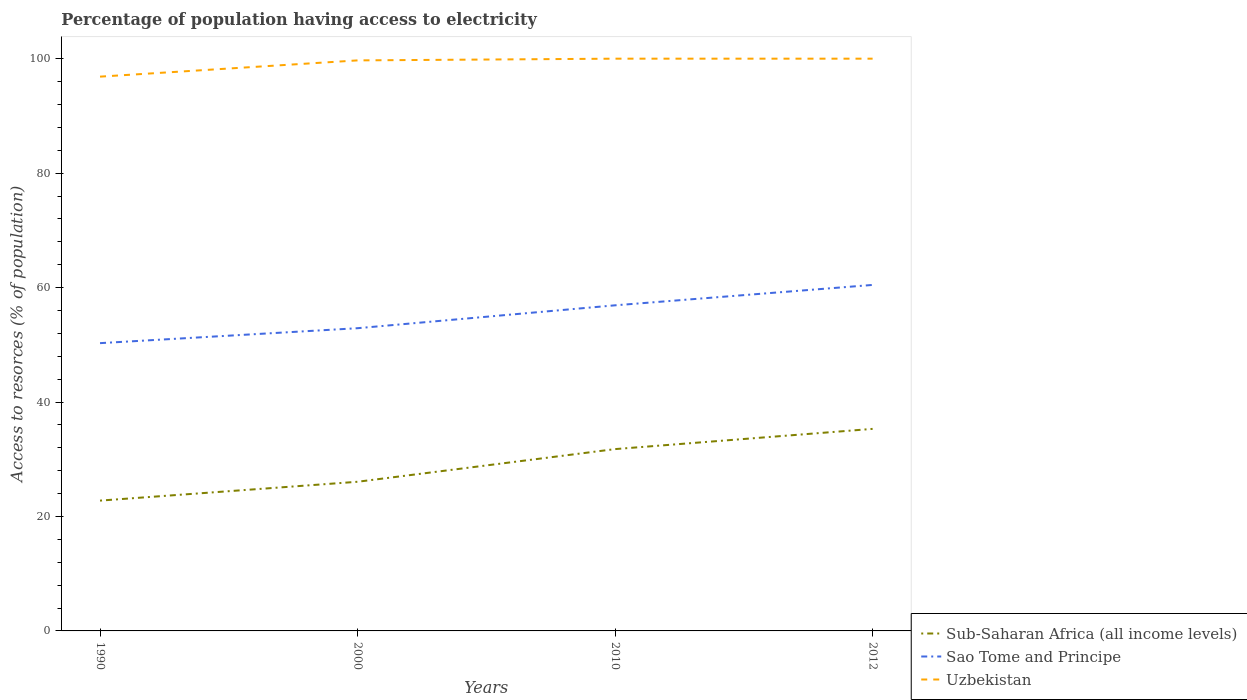How many different coloured lines are there?
Your response must be concise. 3. Across all years, what is the maximum percentage of population having access to electricity in Uzbekistan?
Give a very brief answer. 96.86. What is the difference between the highest and the second highest percentage of population having access to electricity in Uzbekistan?
Keep it short and to the point. 3.14. How many lines are there?
Ensure brevity in your answer.  3. How many years are there in the graph?
Give a very brief answer. 4. Does the graph contain any zero values?
Provide a succinct answer. No. How many legend labels are there?
Provide a succinct answer. 3. What is the title of the graph?
Make the answer very short. Percentage of population having access to electricity. Does "Panama" appear as one of the legend labels in the graph?
Offer a very short reply. No. What is the label or title of the Y-axis?
Keep it short and to the point. Access to resorces (% of population). What is the Access to resorces (% of population) of Sub-Saharan Africa (all income levels) in 1990?
Offer a very short reply. 22.77. What is the Access to resorces (% of population) in Sao Tome and Principe in 1990?
Give a very brief answer. 50.29. What is the Access to resorces (% of population) in Uzbekistan in 1990?
Keep it short and to the point. 96.86. What is the Access to resorces (% of population) of Sub-Saharan Africa (all income levels) in 2000?
Your answer should be very brief. 26.06. What is the Access to resorces (% of population) in Sao Tome and Principe in 2000?
Offer a very short reply. 52.9. What is the Access to resorces (% of population) in Uzbekistan in 2000?
Provide a succinct answer. 99.7. What is the Access to resorces (% of population) of Sub-Saharan Africa (all income levels) in 2010?
Offer a very short reply. 31.77. What is the Access to resorces (% of population) in Sao Tome and Principe in 2010?
Your answer should be compact. 56.9. What is the Access to resorces (% of population) in Uzbekistan in 2010?
Keep it short and to the point. 100. What is the Access to resorces (% of population) in Sub-Saharan Africa (all income levels) in 2012?
Ensure brevity in your answer.  35.31. What is the Access to resorces (% of population) in Sao Tome and Principe in 2012?
Make the answer very short. 60.46. What is the Access to resorces (% of population) of Uzbekistan in 2012?
Provide a succinct answer. 100. Across all years, what is the maximum Access to resorces (% of population) in Sub-Saharan Africa (all income levels)?
Make the answer very short. 35.31. Across all years, what is the maximum Access to resorces (% of population) in Sao Tome and Principe?
Offer a terse response. 60.46. Across all years, what is the maximum Access to resorces (% of population) of Uzbekistan?
Your answer should be compact. 100. Across all years, what is the minimum Access to resorces (% of population) of Sub-Saharan Africa (all income levels)?
Keep it short and to the point. 22.77. Across all years, what is the minimum Access to resorces (% of population) of Sao Tome and Principe?
Provide a short and direct response. 50.29. Across all years, what is the minimum Access to resorces (% of population) in Uzbekistan?
Make the answer very short. 96.86. What is the total Access to resorces (% of population) in Sub-Saharan Africa (all income levels) in the graph?
Keep it short and to the point. 115.92. What is the total Access to resorces (% of population) of Sao Tome and Principe in the graph?
Make the answer very short. 220.55. What is the total Access to resorces (% of population) in Uzbekistan in the graph?
Offer a very short reply. 396.56. What is the difference between the Access to resorces (% of population) of Sub-Saharan Africa (all income levels) in 1990 and that in 2000?
Offer a very short reply. -3.29. What is the difference between the Access to resorces (% of population) in Sao Tome and Principe in 1990 and that in 2000?
Your answer should be compact. -2.61. What is the difference between the Access to resorces (% of population) in Uzbekistan in 1990 and that in 2000?
Provide a succinct answer. -2.84. What is the difference between the Access to resorces (% of population) in Sub-Saharan Africa (all income levels) in 1990 and that in 2010?
Ensure brevity in your answer.  -9. What is the difference between the Access to resorces (% of population) in Sao Tome and Principe in 1990 and that in 2010?
Make the answer very short. -6.61. What is the difference between the Access to resorces (% of population) of Uzbekistan in 1990 and that in 2010?
Your answer should be very brief. -3.14. What is the difference between the Access to resorces (% of population) in Sub-Saharan Africa (all income levels) in 1990 and that in 2012?
Ensure brevity in your answer.  -12.53. What is the difference between the Access to resorces (% of population) of Sao Tome and Principe in 1990 and that in 2012?
Give a very brief answer. -10.17. What is the difference between the Access to resorces (% of population) of Uzbekistan in 1990 and that in 2012?
Provide a short and direct response. -3.14. What is the difference between the Access to resorces (% of population) of Sub-Saharan Africa (all income levels) in 2000 and that in 2010?
Give a very brief answer. -5.71. What is the difference between the Access to resorces (% of population) of Sub-Saharan Africa (all income levels) in 2000 and that in 2012?
Make the answer very short. -9.24. What is the difference between the Access to resorces (% of population) of Sao Tome and Principe in 2000 and that in 2012?
Keep it short and to the point. -7.56. What is the difference between the Access to resorces (% of population) of Sub-Saharan Africa (all income levels) in 2010 and that in 2012?
Ensure brevity in your answer.  -3.53. What is the difference between the Access to resorces (% of population) in Sao Tome and Principe in 2010 and that in 2012?
Provide a succinct answer. -3.56. What is the difference between the Access to resorces (% of population) of Uzbekistan in 2010 and that in 2012?
Your response must be concise. 0. What is the difference between the Access to resorces (% of population) in Sub-Saharan Africa (all income levels) in 1990 and the Access to resorces (% of population) in Sao Tome and Principe in 2000?
Provide a succinct answer. -30.13. What is the difference between the Access to resorces (% of population) of Sub-Saharan Africa (all income levels) in 1990 and the Access to resorces (% of population) of Uzbekistan in 2000?
Give a very brief answer. -76.93. What is the difference between the Access to resorces (% of population) of Sao Tome and Principe in 1990 and the Access to resorces (% of population) of Uzbekistan in 2000?
Your answer should be very brief. -49.41. What is the difference between the Access to resorces (% of population) of Sub-Saharan Africa (all income levels) in 1990 and the Access to resorces (% of population) of Sao Tome and Principe in 2010?
Provide a short and direct response. -34.13. What is the difference between the Access to resorces (% of population) of Sub-Saharan Africa (all income levels) in 1990 and the Access to resorces (% of population) of Uzbekistan in 2010?
Offer a very short reply. -77.23. What is the difference between the Access to resorces (% of population) of Sao Tome and Principe in 1990 and the Access to resorces (% of population) of Uzbekistan in 2010?
Keep it short and to the point. -49.71. What is the difference between the Access to resorces (% of population) of Sub-Saharan Africa (all income levels) in 1990 and the Access to resorces (% of population) of Sao Tome and Principe in 2012?
Your response must be concise. -37.69. What is the difference between the Access to resorces (% of population) of Sub-Saharan Africa (all income levels) in 1990 and the Access to resorces (% of population) of Uzbekistan in 2012?
Ensure brevity in your answer.  -77.23. What is the difference between the Access to resorces (% of population) of Sao Tome and Principe in 1990 and the Access to resorces (% of population) of Uzbekistan in 2012?
Your answer should be very brief. -49.71. What is the difference between the Access to resorces (% of population) in Sub-Saharan Africa (all income levels) in 2000 and the Access to resorces (% of population) in Sao Tome and Principe in 2010?
Offer a very short reply. -30.84. What is the difference between the Access to resorces (% of population) in Sub-Saharan Africa (all income levels) in 2000 and the Access to resorces (% of population) in Uzbekistan in 2010?
Your answer should be very brief. -73.94. What is the difference between the Access to resorces (% of population) of Sao Tome and Principe in 2000 and the Access to resorces (% of population) of Uzbekistan in 2010?
Ensure brevity in your answer.  -47.1. What is the difference between the Access to resorces (% of population) in Sub-Saharan Africa (all income levels) in 2000 and the Access to resorces (% of population) in Sao Tome and Principe in 2012?
Provide a short and direct response. -34.4. What is the difference between the Access to resorces (% of population) in Sub-Saharan Africa (all income levels) in 2000 and the Access to resorces (% of population) in Uzbekistan in 2012?
Provide a succinct answer. -73.94. What is the difference between the Access to resorces (% of population) of Sao Tome and Principe in 2000 and the Access to resorces (% of population) of Uzbekistan in 2012?
Your response must be concise. -47.1. What is the difference between the Access to resorces (% of population) in Sub-Saharan Africa (all income levels) in 2010 and the Access to resorces (% of population) in Sao Tome and Principe in 2012?
Your answer should be compact. -28.69. What is the difference between the Access to resorces (% of population) in Sub-Saharan Africa (all income levels) in 2010 and the Access to resorces (% of population) in Uzbekistan in 2012?
Give a very brief answer. -68.23. What is the difference between the Access to resorces (% of population) of Sao Tome and Principe in 2010 and the Access to resorces (% of population) of Uzbekistan in 2012?
Keep it short and to the point. -43.1. What is the average Access to resorces (% of population) of Sub-Saharan Africa (all income levels) per year?
Make the answer very short. 28.98. What is the average Access to resorces (% of population) in Sao Tome and Principe per year?
Provide a short and direct response. 55.14. What is the average Access to resorces (% of population) in Uzbekistan per year?
Your response must be concise. 99.14. In the year 1990, what is the difference between the Access to resorces (% of population) in Sub-Saharan Africa (all income levels) and Access to resorces (% of population) in Sao Tome and Principe?
Offer a terse response. -27.52. In the year 1990, what is the difference between the Access to resorces (% of population) in Sub-Saharan Africa (all income levels) and Access to resorces (% of population) in Uzbekistan?
Your answer should be very brief. -74.09. In the year 1990, what is the difference between the Access to resorces (% of population) in Sao Tome and Principe and Access to resorces (% of population) in Uzbekistan?
Your response must be concise. -46.57. In the year 2000, what is the difference between the Access to resorces (% of population) in Sub-Saharan Africa (all income levels) and Access to resorces (% of population) in Sao Tome and Principe?
Your response must be concise. -26.84. In the year 2000, what is the difference between the Access to resorces (% of population) of Sub-Saharan Africa (all income levels) and Access to resorces (% of population) of Uzbekistan?
Provide a short and direct response. -73.64. In the year 2000, what is the difference between the Access to resorces (% of population) in Sao Tome and Principe and Access to resorces (% of population) in Uzbekistan?
Give a very brief answer. -46.8. In the year 2010, what is the difference between the Access to resorces (% of population) of Sub-Saharan Africa (all income levels) and Access to resorces (% of population) of Sao Tome and Principe?
Ensure brevity in your answer.  -25.13. In the year 2010, what is the difference between the Access to resorces (% of population) in Sub-Saharan Africa (all income levels) and Access to resorces (% of population) in Uzbekistan?
Ensure brevity in your answer.  -68.23. In the year 2010, what is the difference between the Access to resorces (% of population) of Sao Tome and Principe and Access to resorces (% of population) of Uzbekistan?
Your response must be concise. -43.1. In the year 2012, what is the difference between the Access to resorces (% of population) of Sub-Saharan Africa (all income levels) and Access to resorces (% of population) of Sao Tome and Principe?
Provide a short and direct response. -25.16. In the year 2012, what is the difference between the Access to resorces (% of population) of Sub-Saharan Africa (all income levels) and Access to resorces (% of population) of Uzbekistan?
Keep it short and to the point. -64.69. In the year 2012, what is the difference between the Access to resorces (% of population) of Sao Tome and Principe and Access to resorces (% of population) of Uzbekistan?
Make the answer very short. -39.54. What is the ratio of the Access to resorces (% of population) in Sub-Saharan Africa (all income levels) in 1990 to that in 2000?
Your answer should be very brief. 0.87. What is the ratio of the Access to resorces (% of population) in Sao Tome and Principe in 1990 to that in 2000?
Your response must be concise. 0.95. What is the ratio of the Access to resorces (% of population) in Uzbekistan in 1990 to that in 2000?
Provide a short and direct response. 0.97. What is the ratio of the Access to resorces (% of population) in Sub-Saharan Africa (all income levels) in 1990 to that in 2010?
Offer a terse response. 0.72. What is the ratio of the Access to resorces (% of population) in Sao Tome and Principe in 1990 to that in 2010?
Keep it short and to the point. 0.88. What is the ratio of the Access to resorces (% of population) in Uzbekistan in 1990 to that in 2010?
Your answer should be compact. 0.97. What is the ratio of the Access to resorces (% of population) in Sub-Saharan Africa (all income levels) in 1990 to that in 2012?
Provide a succinct answer. 0.65. What is the ratio of the Access to resorces (% of population) in Sao Tome and Principe in 1990 to that in 2012?
Give a very brief answer. 0.83. What is the ratio of the Access to resorces (% of population) in Uzbekistan in 1990 to that in 2012?
Offer a terse response. 0.97. What is the ratio of the Access to resorces (% of population) in Sub-Saharan Africa (all income levels) in 2000 to that in 2010?
Offer a terse response. 0.82. What is the ratio of the Access to resorces (% of population) in Sao Tome and Principe in 2000 to that in 2010?
Keep it short and to the point. 0.93. What is the ratio of the Access to resorces (% of population) in Sub-Saharan Africa (all income levels) in 2000 to that in 2012?
Keep it short and to the point. 0.74. What is the ratio of the Access to resorces (% of population) in Sao Tome and Principe in 2000 to that in 2012?
Offer a terse response. 0.87. What is the ratio of the Access to resorces (% of population) of Uzbekistan in 2000 to that in 2012?
Ensure brevity in your answer.  1. What is the ratio of the Access to resorces (% of population) in Sub-Saharan Africa (all income levels) in 2010 to that in 2012?
Provide a succinct answer. 0.9. What is the ratio of the Access to resorces (% of population) in Sao Tome and Principe in 2010 to that in 2012?
Ensure brevity in your answer.  0.94. What is the ratio of the Access to resorces (% of population) of Uzbekistan in 2010 to that in 2012?
Provide a short and direct response. 1. What is the difference between the highest and the second highest Access to resorces (% of population) of Sub-Saharan Africa (all income levels)?
Keep it short and to the point. 3.53. What is the difference between the highest and the second highest Access to resorces (% of population) in Sao Tome and Principe?
Your answer should be very brief. 3.56. What is the difference between the highest and the second highest Access to resorces (% of population) in Uzbekistan?
Your response must be concise. 0. What is the difference between the highest and the lowest Access to resorces (% of population) in Sub-Saharan Africa (all income levels)?
Ensure brevity in your answer.  12.53. What is the difference between the highest and the lowest Access to resorces (% of population) of Sao Tome and Principe?
Offer a very short reply. 10.17. What is the difference between the highest and the lowest Access to resorces (% of population) of Uzbekistan?
Ensure brevity in your answer.  3.14. 